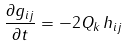<formula> <loc_0><loc_0><loc_500><loc_500>\frac { \partial g _ { i j } } { \partial t } = - 2 Q _ { k } \, h _ { i j }</formula> 